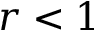<formula> <loc_0><loc_0><loc_500><loc_500>r < 1</formula> 